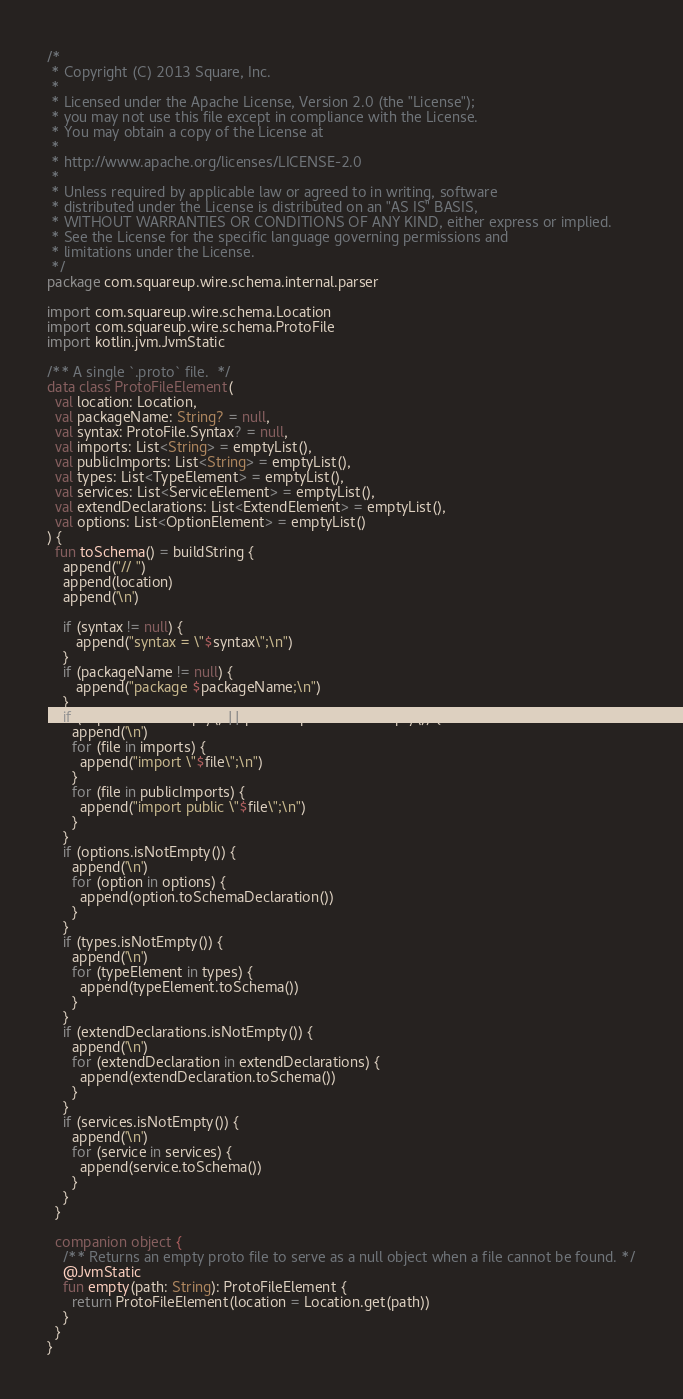<code> <loc_0><loc_0><loc_500><loc_500><_Kotlin_>/*
 * Copyright (C) 2013 Square, Inc.
 *
 * Licensed under the Apache License, Version 2.0 (the "License");
 * you may not use this file except in compliance with the License.
 * You may obtain a copy of the License at
 *
 * http://www.apache.org/licenses/LICENSE-2.0
 *
 * Unless required by applicable law or agreed to in writing, software
 * distributed under the License is distributed on an "AS IS" BASIS,
 * WITHOUT WARRANTIES OR CONDITIONS OF ANY KIND, either express or implied.
 * See the License for the specific language governing permissions and
 * limitations under the License.
 */
package com.squareup.wire.schema.internal.parser

import com.squareup.wire.schema.Location
import com.squareup.wire.schema.ProtoFile
import kotlin.jvm.JvmStatic

/** A single `.proto` file.  */
data class ProtoFileElement(
  val location: Location,
  val packageName: String? = null,
  val syntax: ProtoFile.Syntax? = null,
  val imports: List<String> = emptyList(),
  val publicImports: List<String> = emptyList(),
  val types: List<TypeElement> = emptyList(),
  val services: List<ServiceElement> = emptyList(),
  val extendDeclarations: List<ExtendElement> = emptyList(),
  val options: List<OptionElement> = emptyList()
) {
  fun toSchema() = buildString {
    append("// ")
    append(location)
    append('\n')

    if (syntax != null) {
       append("syntax = \"$syntax\";\n")
    }
    if (packageName != null) {
       append("package $packageName;\n")
    }
    if (imports.isNotEmpty() || publicImports.isNotEmpty()) {
      append('\n')
      for (file in imports) {
        append("import \"$file\";\n")
      }
      for (file in publicImports) {
        append("import public \"$file\";\n")
      }
    }
    if (options.isNotEmpty()) {
      append('\n')
      for (option in options) {
        append(option.toSchemaDeclaration())
      }
    }
    if (types.isNotEmpty()) {
      append('\n')
      for (typeElement in types) {
        append(typeElement.toSchema())
      }
    }
    if (extendDeclarations.isNotEmpty()) {
      append('\n')
      for (extendDeclaration in extendDeclarations) {
        append(extendDeclaration.toSchema())
      }
    }
    if (services.isNotEmpty()) {
      append('\n')
      for (service in services) {
        append(service.toSchema())
      }
    }
  }

  companion object {
    /** Returns an empty proto file to serve as a null object when a file cannot be found. */
    @JvmStatic
    fun empty(path: String): ProtoFileElement {
      return ProtoFileElement(location = Location.get(path))
    }
  }
}
</code> 